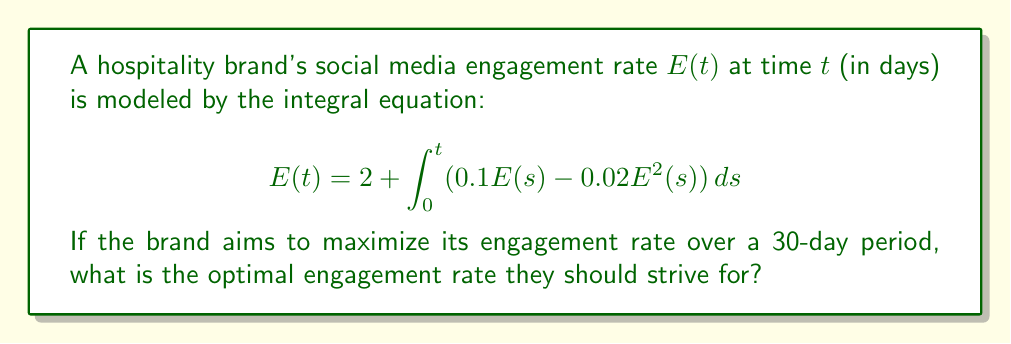Provide a solution to this math problem. To find the optimal engagement rate, we need to solve the integral equation and find its maximum value:

1) First, differentiate both sides of the equation with respect to $t$:

   $$\frac{dE}{dt} = 0.1E(t) - 0.02E^2(t)$$

2) To find the optimal (maximum) engagement rate, set $\frac{dE}{dt} = 0$:

   $$0 = 0.1E - 0.02E^2$$

3) Factor out $E$:

   $$E(0.1 - 0.02E) = 0$$

4) Solve for $E$:
   
   $E = 0$ or $0.1 - 0.02E = 0$
   
   From the second equation: $0.02E = 0.1$, so $E = 5$

5) $E = 0$ is not a valid solution as it represents zero engagement. Therefore, the optimal engagement rate is 5.

6) Verify that this is a maximum by checking the second derivative:

   $$\frac{d^2E}{dt^2} = 0.1\frac{dE}{dt} - 0.04E\frac{dE}{dt} = (0.1 - 0.04E)\frac{dE}{dt}$$

   At $E = 5$, this becomes negative, confirming it's a maximum.
Answer: 5 